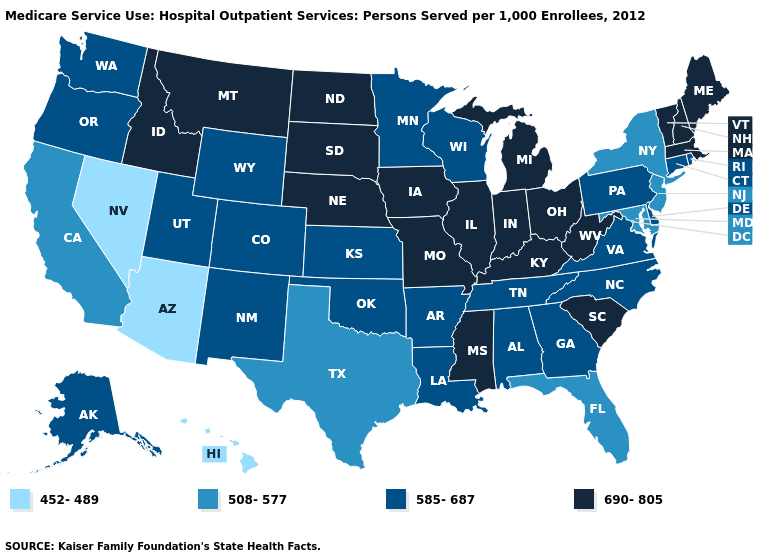What is the lowest value in states that border Pennsylvania?
Concise answer only. 508-577. Does Florida have a lower value than Oregon?
Give a very brief answer. Yes. Name the states that have a value in the range 690-805?
Be succinct. Idaho, Illinois, Indiana, Iowa, Kentucky, Maine, Massachusetts, Michigan, Mississippi, Missouri, Montana, Nebraska, New Hampshire, North Dakota, Ohio, South Carolina, South Dakota, Vermont, West Virginia. Among the states that border New Hampshire , which have the lowest value?
Concise answer only. Maine, Massachusetts, Vermont. Name the states that have a value in the range 585-687?
Short answer required. Alabama, Alaska, Arkansas, Colorado, Connecticut, Delaware, Georgia, Kansas, Louisiana, Minnesota, New Mexico, North Carolina, Oklahoma, Oregon, Pennsylvania, Rhode Island, Tennessee, Utah, Virginia, Washington, Wisconsin, Wyoming. Name the states that have a value in the range 690-805?
Keep it brief. Idaho, Illinois, Indiana, Iowa, Kentucky, Maine, Massachusetts, Michigan, Mississippi, Missouri, Montana, Nebraska, New Hampshire, North Dakota, Ohio, South Carolina, South Dakota, Vermont, West Virginia. Which states have the lowest value in the USA?
Concise answer only. Arizona, Hawaii, Nevada. What is the lowest value in the USA?
Give a very brief answer. 452-489. Name the states that have a value in the range 585-687?
Give a very brief answer. Alabama, Alaska, Arkansas, Colorado, Connecticut, Delaware, Georgia, Kansas, Louisiana, Minnesota, New Mexico, North Carolina, Oklahoma, Oregon, Pennsylvania, Rhode Island, Tennessee, Utah, Virginia, Washington, Wisconsin, Wyoming. Name the states that have a value in the range 690-805?
Answer briefly. Idaho, Illinois, Indiana, Iowa, Kentucky, Maine, Massachusetts, Michigan, Mississippi, Missouri, Montana, Nebraska, New Hampshire, North Dakota, Ohio, South Carolina, South Dakota, Vermont, West Virginia. Does the map have missing data?
Quick response, please. No. What is the highest value in states that border Georgia?
Quick response, please. 690-805. Does North Carolina have a lower value than Georgia?
Give a very brief answer. No. Does the map have missing data?
Answer briefly. No. Which states have the highest value in the USA?
Short answer required. Idaho, Illinois, Indiana, Iowa, Kentucky, Maine, Massachusetts, Michigan, Mississippi, Missouri, Montana, Nebraska, New Hampshire, North Dakota, Ohio, South Carolina, South Dakota, Vermont, West Virginia. 